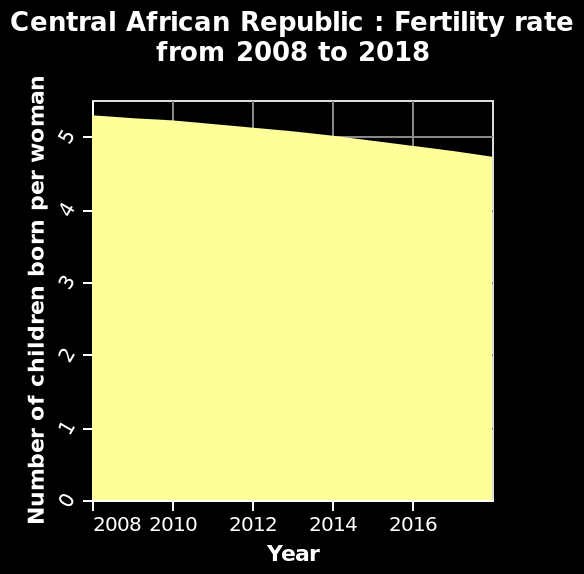<image>
What does the area chart show about the fertility rate in Central African Republic?  The area chart shows a slight decrease in the fertility rate in Central African Republic from 2008 to 2018. please describe the details of the chart Here a area graph is titled Central African Republic : Fertility rate from 2008 to 2018. A linear scale with a minimum of 2008 and a maximum of 2016 can be found on the x-axis, labeled Year. The y-axis plots Number of children born per woman. What is the title of the area graph?  The title of the area graph is "Central African Republic: Fertility rate from 2008 to 2018." What is the scale of the x-axis? The x-axis scale is linear. 